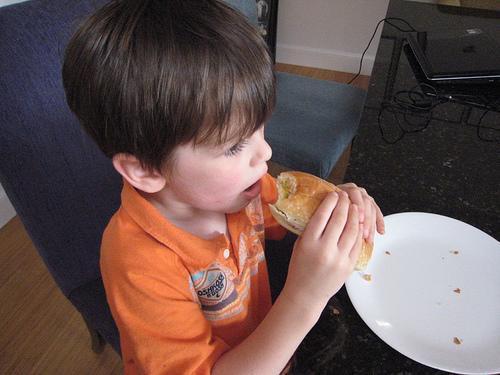How many chairs are shown?
Give a very brief answer. 2. How many chairs are visible?
Give a very brief answer. 2. 